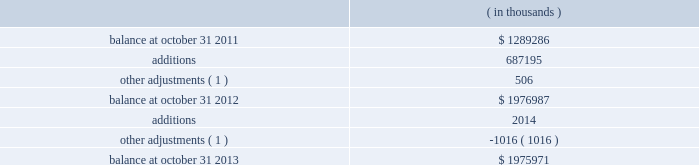Synopsys , inc .
Notes to consolidated financial statements 2014continued acquired identifiable intangible assets of $ 107.3 million , resulting in total goodwill of $ 257.6 million .
Identifiable intangible assets are being amortized over three to eight years .
Acquisition-related costs directly attributable to the business combination were $ 6.6 million for fiscal 2012 and were expensed as incurred in the consolidated statements of operations .
These costs consisted primarily of employee separation costs and professional services .
Acquisition of magma design automation , inc .
( magma ) on february 22 , 2012 , the company acquired magma , a chip design software provider , at a per- share price of $ 7.35 .
Additionally , the company assumed unvested restricted stock units ( rsus ) and stock options , collectively called 201cequity awards . 201d the aggregate purchase price was approximately $ 550.2 million .
This acquisition enables the company to more rapidly meet the needs of leading-edge semiconductor designers for more sophisticated design tools .
The company allocated the total purchase consideration of $ 550.2 million ( including $ 6.8 million related to equity awards assumed ) to the assets acquired and liabilities assumed based on their respective fair values at the acquisition date , including acquired identifiable intangible assets of $ 184.3 million , resulting in total goodwill of $ 316.3 million .
Identifiable intangible assets are being amortized over three to ten years .
Acquisition-related costs directly attributable to the business combination totaling $ 33.5 million for fiscal 2012 were expensed as incurred in the consolidated statements of operations and consist primarily of employee separation costs , contract terminations , professional services , and facilities closure costs .
Other fiscal 2012 acquisitions during fiscal 2012 , the company acquired five other companies , including emulation & verification engineering , s.a .
( eve ) , for cash and allocated the total purchase consideration of $ 213.2 million to the assets acquired and liabilities assumed based on their respective fair values , resulting in total goodwill of $ 118.1 million .
Acquired identifiable intangible assets totaling $ 73.3 million were valued using appropriate valuation methods such as income or cost methods and are being amortized over their respective useful lives ranging from one to eight years .
During fiscal 2012 , acquisition-related costs totaling $ 6.8 million were expensed as incurred in the consolidated statements of operations .
Fiscal 2011 acquisitions during fiscal 2011 , the company completed two acquisitions for cash and allocated the total purchase consideration of $ 37.4 million to the assets and liabilities acquired based on their respective fair values at the acquisition date resulting in goodwill of $ 30.6 million .
Acquired identifiable intangible assets of $ 9.3 million are being amortized over two to ten years .
Note 4 .
Goodwill and intangible assets goodwill: .

What is the percentual decrease observed in the balance between 2012 and 2013?\\n? 
Rationale: it is the variation divided by the initial value , then turned into a percentage .
Computations: ((1975971 - 1976987) / 1976987)
Answer: -0.00051. 